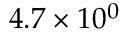<formula> <loc_0><loc_0><loc_500><loc_500>4 . 7 \times 1 0 ^ { 0 }</formula> 